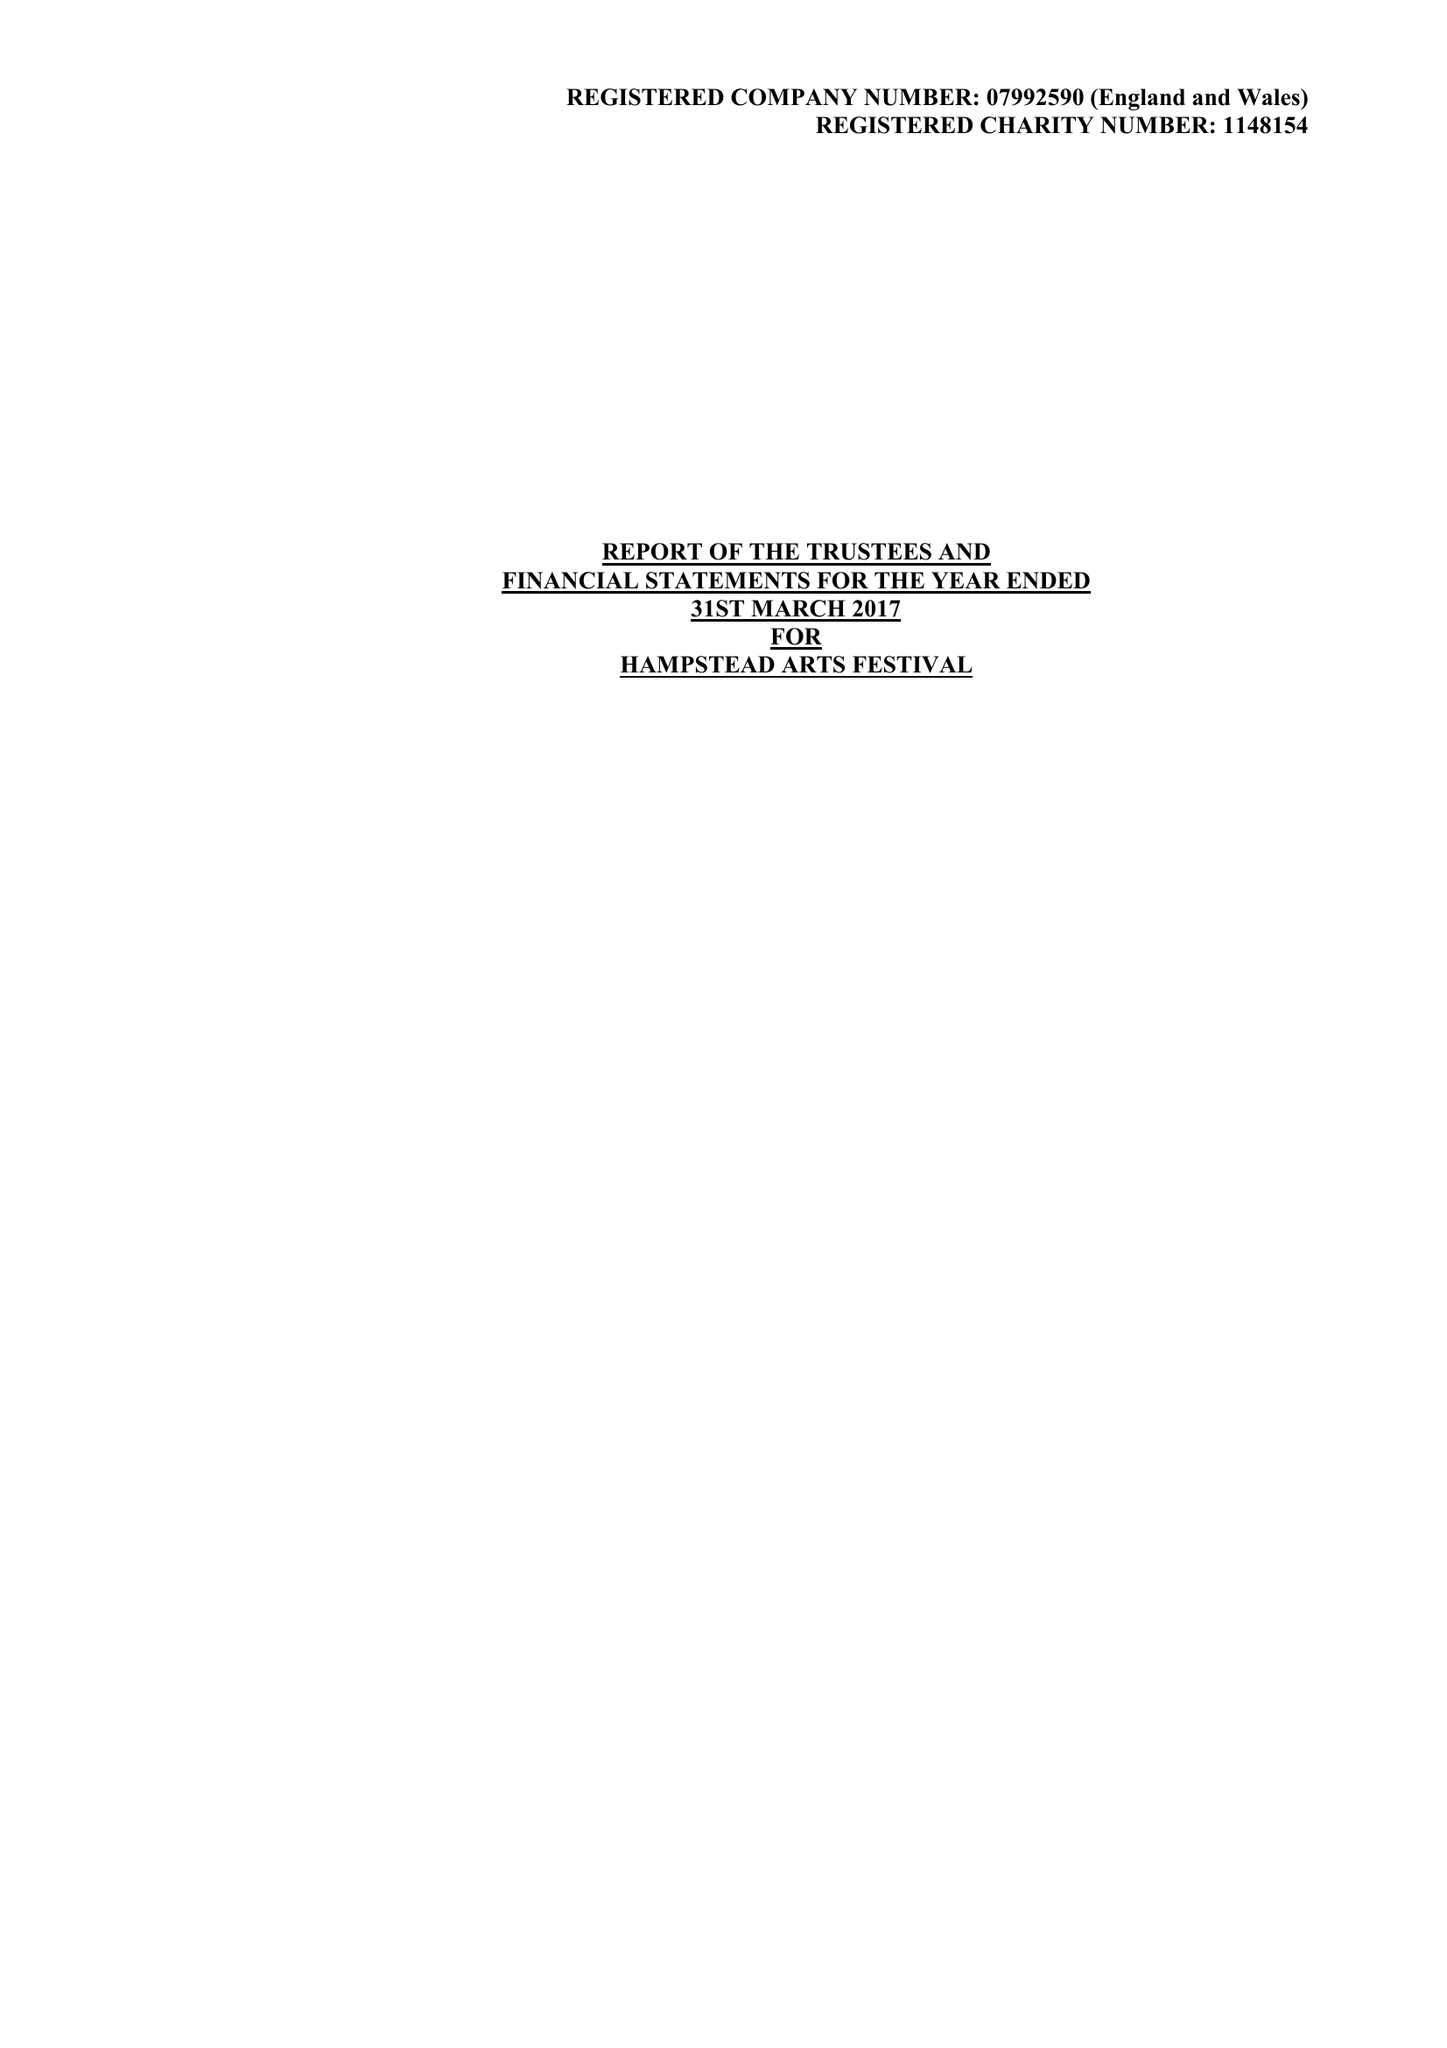What is the value for the report_date?
Answer the question using a single word or phrase. 2017-03-31 